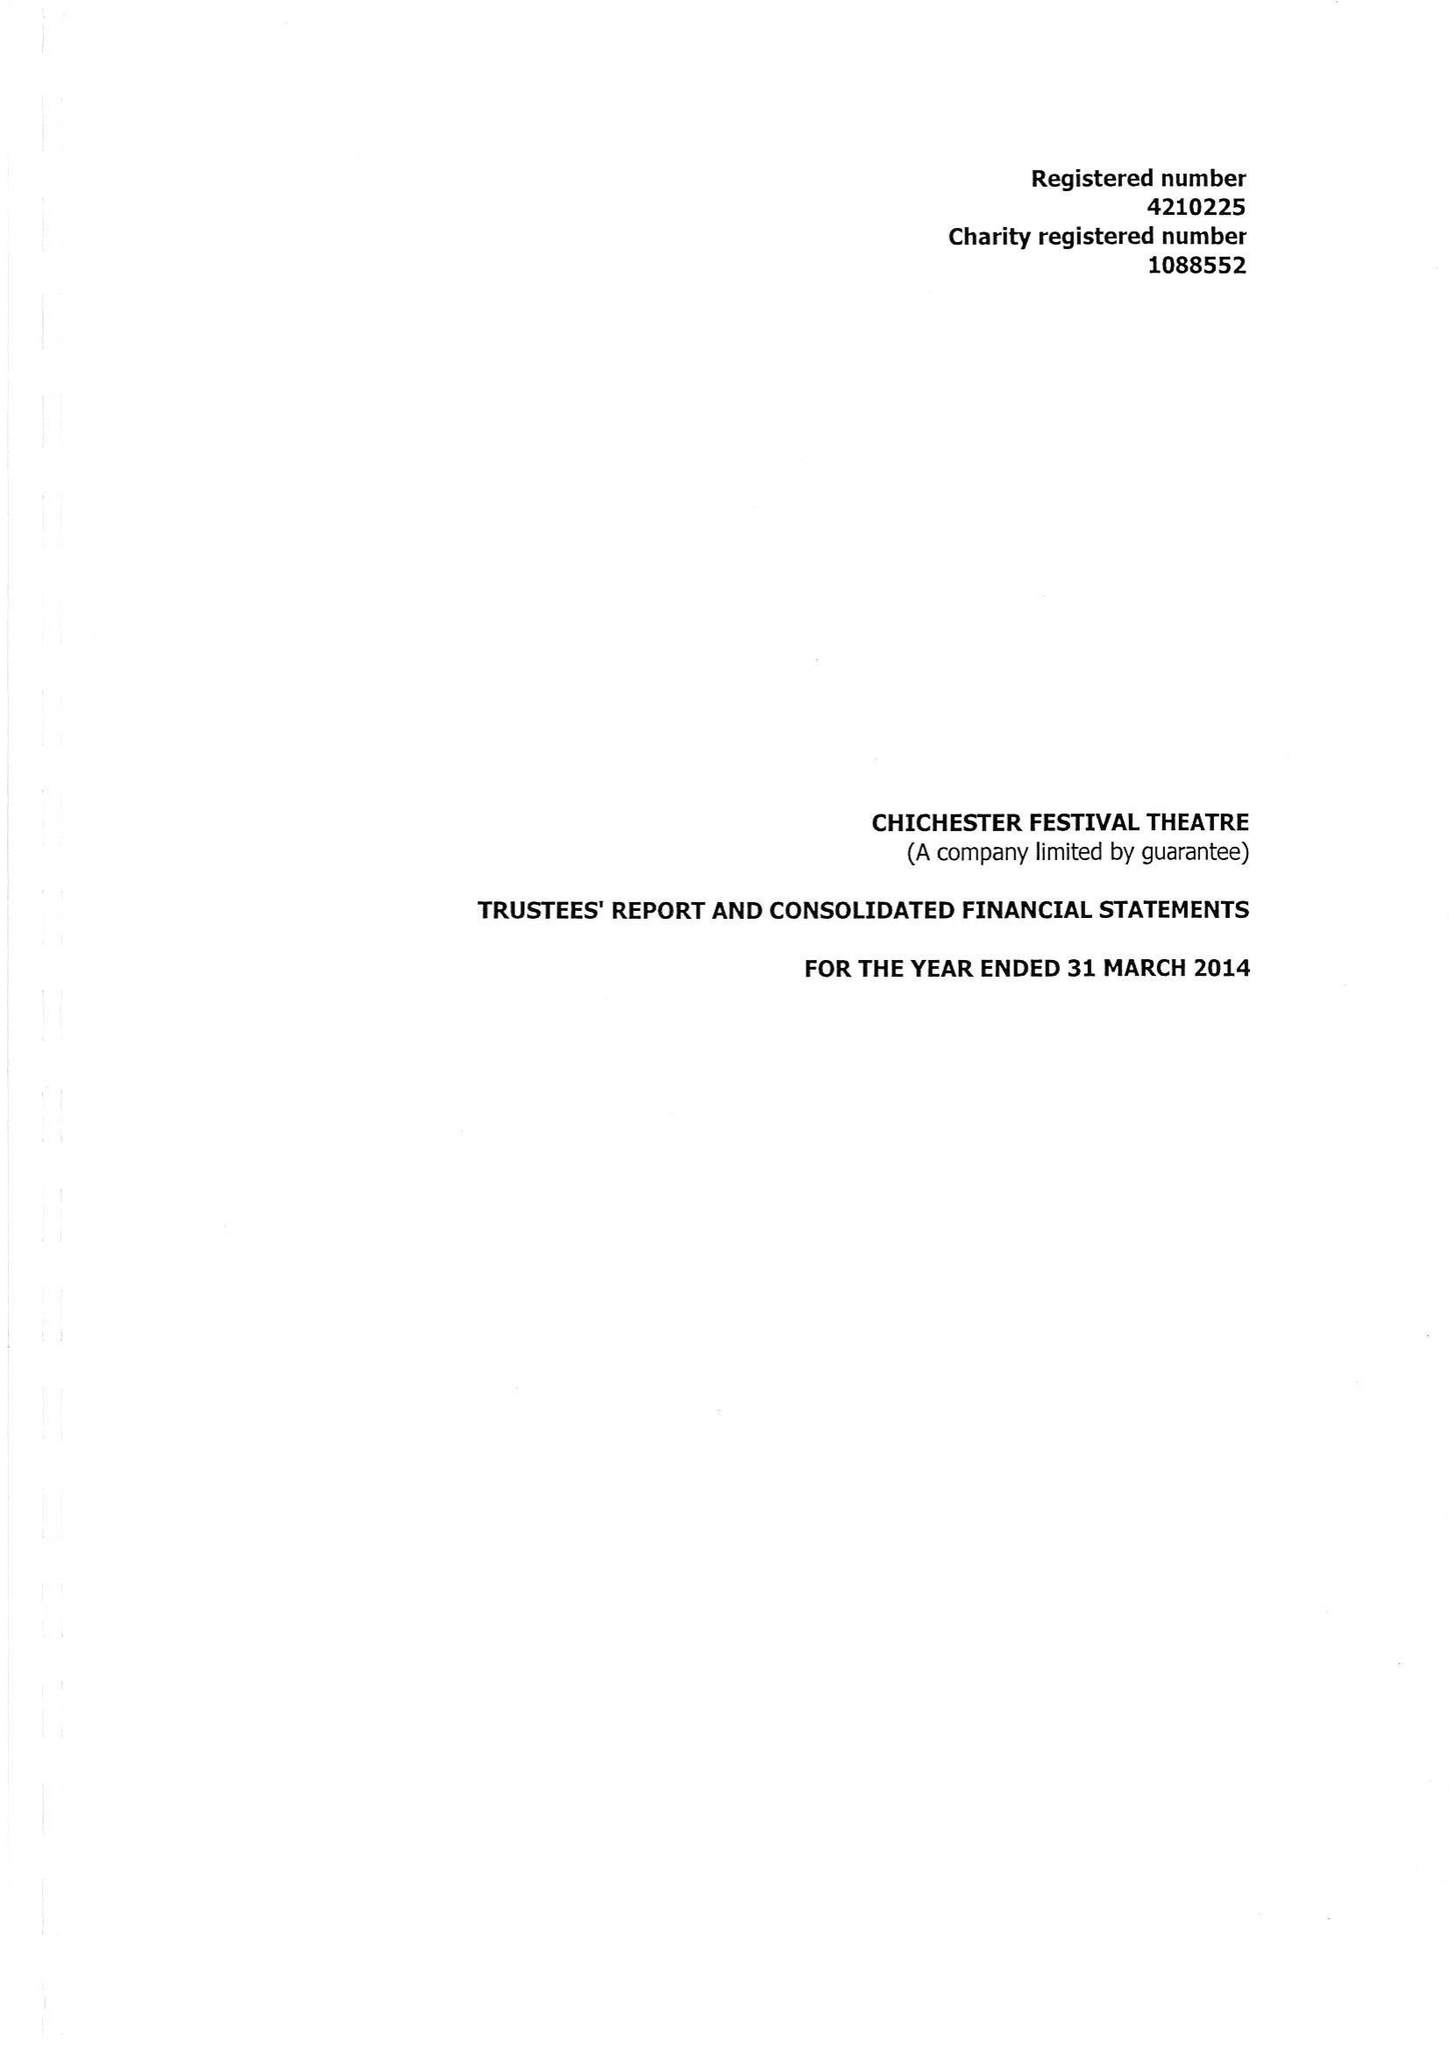What is the value for the address__postcode?
Answer the question using a single word or phrase. PO19 6AP 